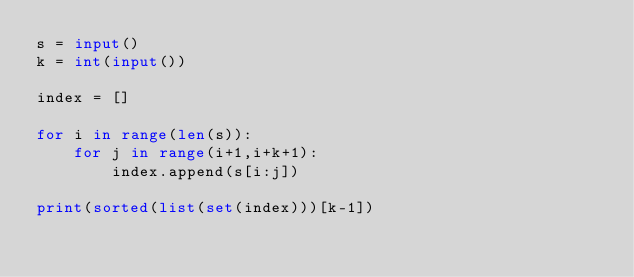<code> <loc_0><loc_0><loc_500><loc_500><_Python_>s = input()
k = int(input())

index = []

for i in range(len(s)):
    for j in range(i+1,i+k+1):
        index.append(s[i:j])
    
print(sorted(list(set(index)))[k-1])
</code> 